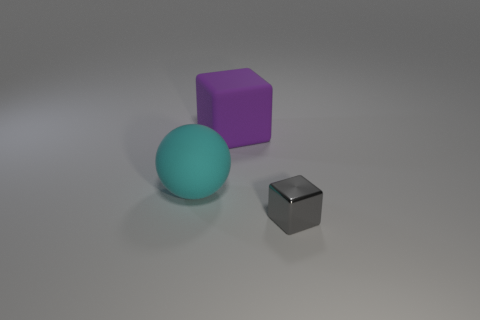What lighting conditions are present in the image? The lighting in the image is diffused and soft, creating gentle shadows on the ground beneath the objects. There doesn't appear to be a single strong light source, but rather an ambient light that illuminates the scene uniformly, possibly suggesting an overcast sky or a photography studio setup. How might the lighting affect the perception of the object's colors? The diffused lighting can lead to more true-to-life colors, as harsh shadows or bright highlights that can alter the perception of color are minimized. This type of lighting ensures the colors are perceived consistently, without strong alterations due to the light's angle or intensity. 